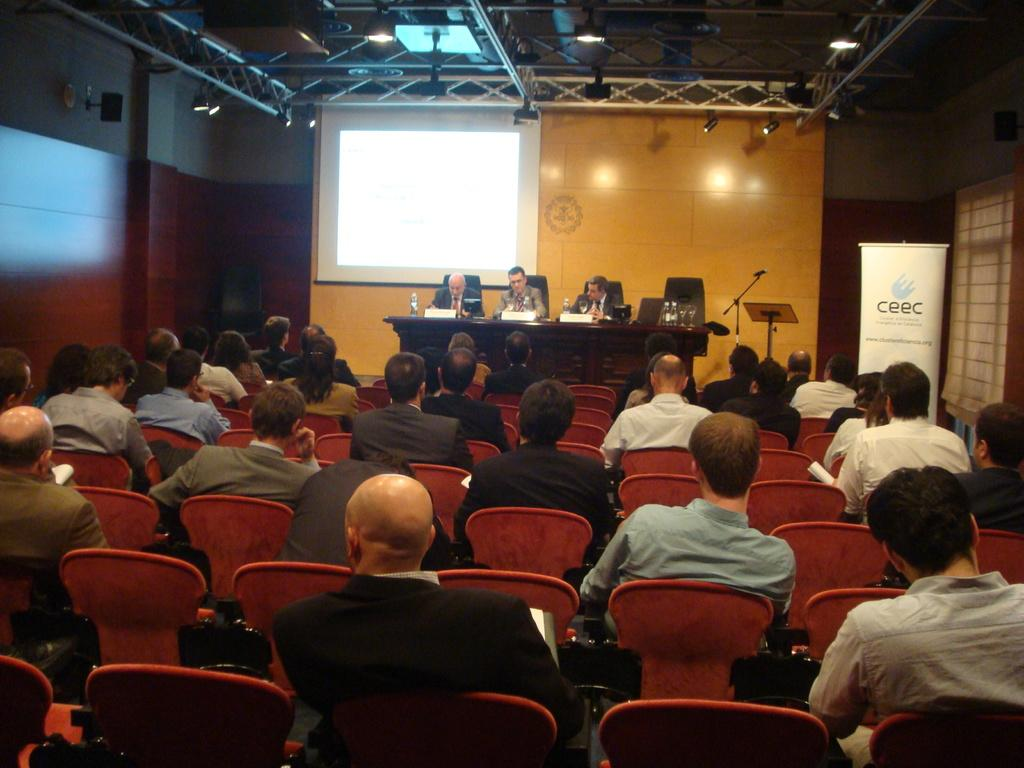What are the people in the image doing? The people in the image are sitting and listening to something. Can you describe the people on the stage? There are three men on a stage. What type of plastic is used to make the shelf in the image? There is no shelf present in the image. 